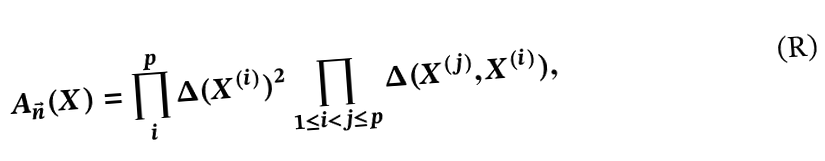Convert formula to latex. <formula><loc_0><loc_0><loc_500><loc_500>A _ { \vec { n } } ( X ) = \prod _ { i } ^ { p } \Delta ( X ^ { ( i ) } ) ^ { 2 } \prod _ { 1 \leq i < j \leq p } \Delta ( X ^ { ( j ) } , X ^ { ( i ) } ) ,</formula> 